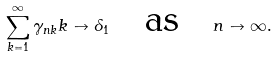Convert formula to latex. <formula><loc_0><loc_0><loc_500><loc_500>\sum _ { k = 1 } ^ { \infty } \gamma _ { n k } k \to \delta _ { 1 } \quad \text {as} \quad n \to \infty .</formula> 